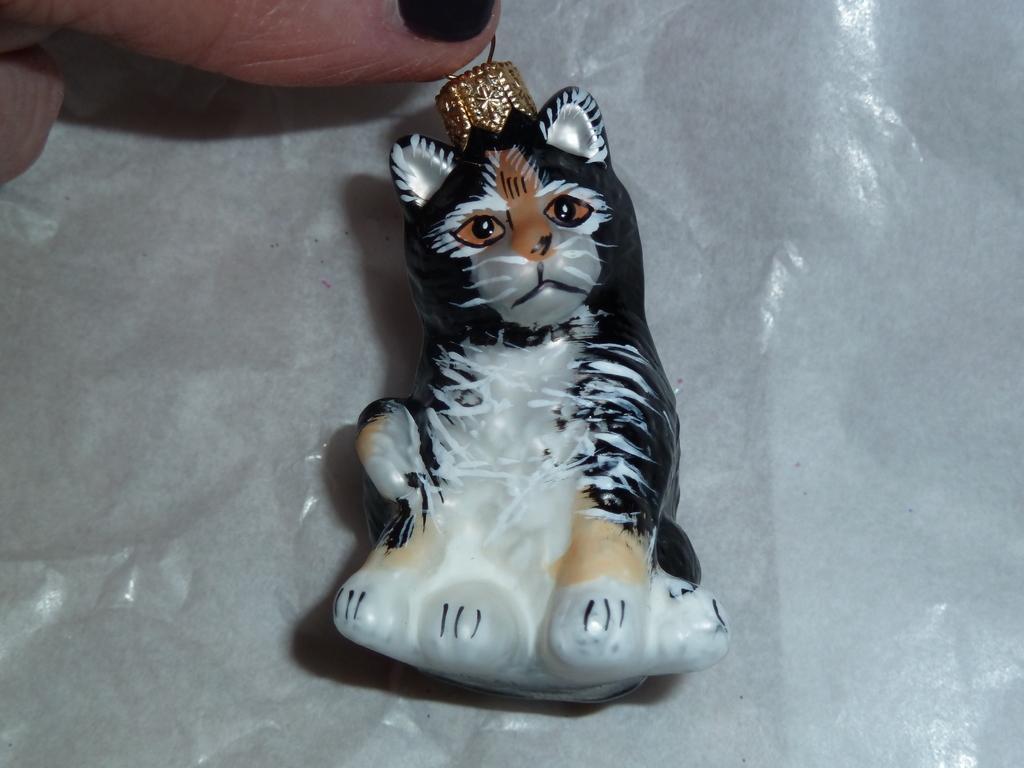In one or two sentences, can you explain what this image depicts? In the center of the image a toy is present. At the top left corner a person finger is there. 